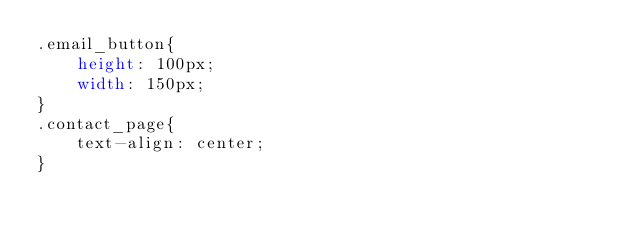Convert code to text. <code><loc_0><loc_0><loc_500><loc_500><_CSS_>.email_button{
    height: 100px;
    width: 150px;
}
.contact_page{
    text-align: center;
}</code> 